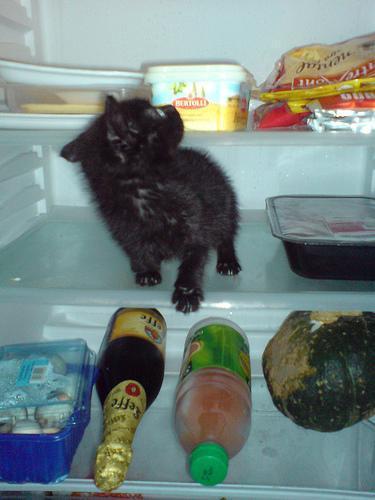How many cats are in the fridge?
Give a very brief answer. 1. 